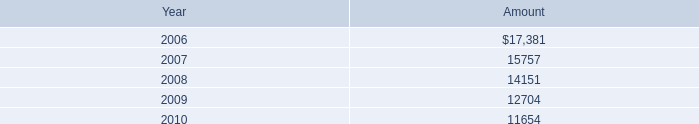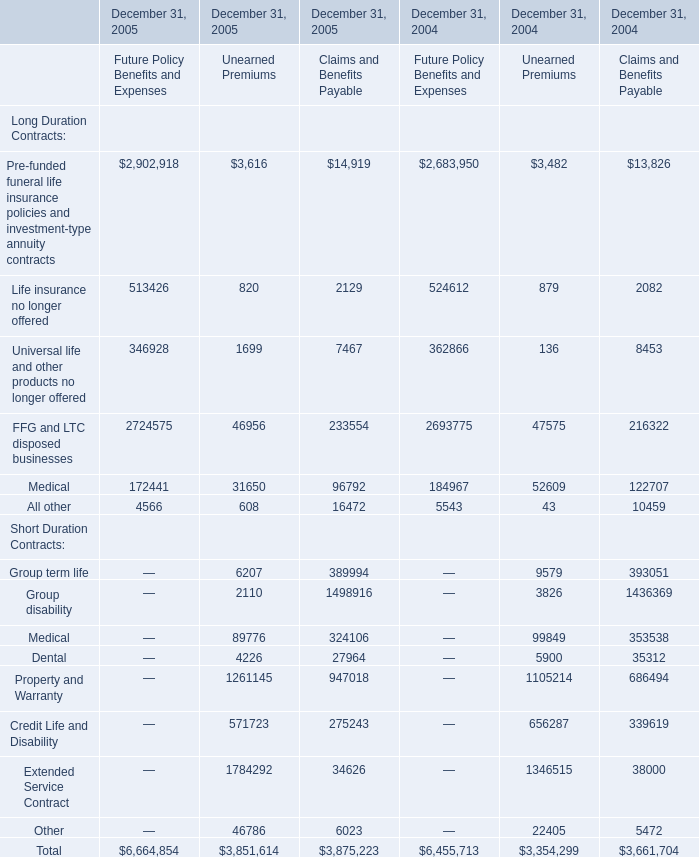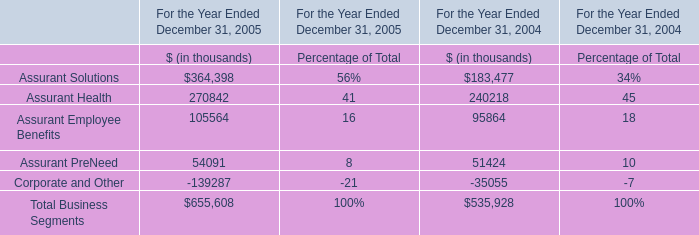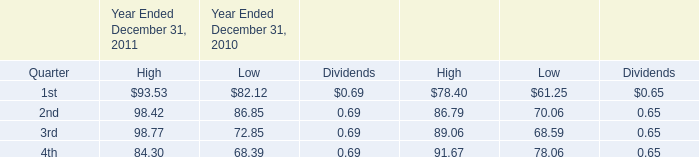in december 2011 , what was the total dollar value of the vornado common shares rceived as payment for the exercise of certain employee options? 
Computations: (76.36 * 410783)
Answer: 31367389.88. 